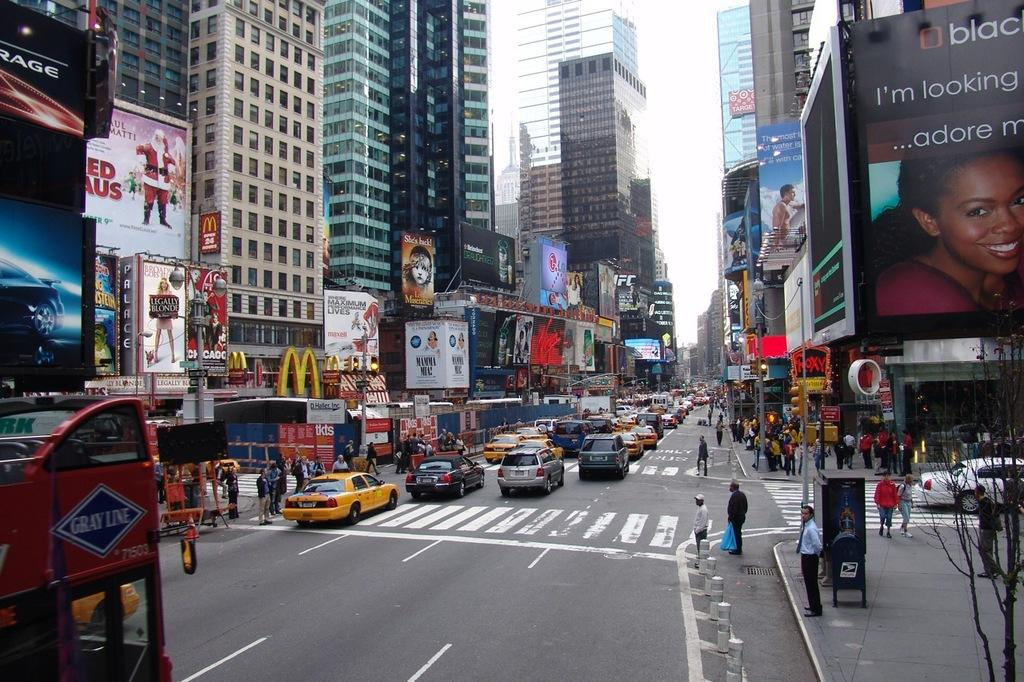<image>
Offer a succinct explanation of the picture presented. Legally Blonde is playing at the Palace according to the large sign. 